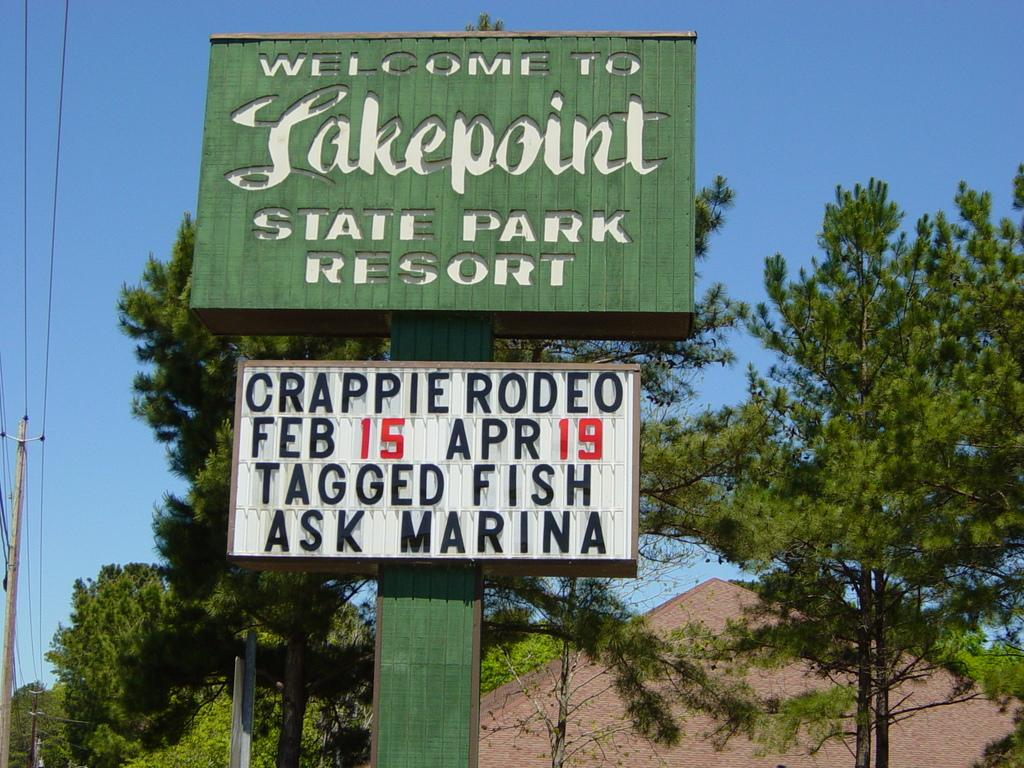What objects can be seen in the image that are related to construction or infrastructure? In the image, there are boards, poles, and wires, which are related to construction or infrastructure. What type of natural elements are present in the image? There are trees in the image, which are a natural element. What structure is visible in the image? There is a roof in the image, which suggests the presence of a building or structure. What can be seen in the background of the image? The sky is visible in the background of the image. What type of lift can be seen in the image? There is no lift present in the image. What role does the minister play in the image? There is no minister present in the image. 